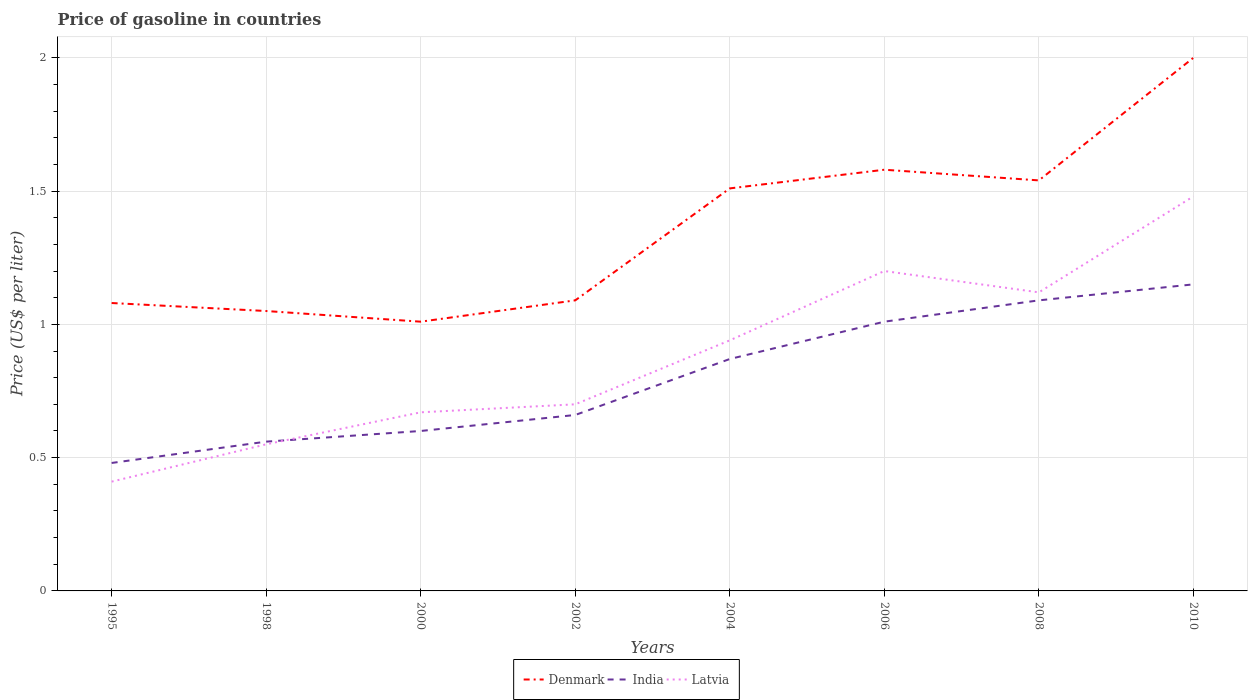How many different coloured lines are there?
Your answer should be compact. 3. Does the line corresponding to Latvia intersect with the line corresponding to India?
Provide a short and direct response. Yes. Across all years, what is the maximum price of gasoline in Latvia?
Give a very brief answer. 0.41. What is the total price of gasoline in Denmark in the graph?
Ensure brevity in your answer.  -0.08. What is the difference between the highest and the second highest price of gasoline in India?
Give a very brief answer. 0.67. What is the difference between the highest and the lowest price of gasoline in Latvia?
Your answer should be compact. 4. Is the price of gasoline in India strictly greater than the price of gasoline in Denmark over the years?
Make the answer very short. Yes. How many lines are there?
Give a very brief answer. 3. Are the values on the major ticks of Y-axis written in scientific E-notation?
Provide a short and direct response. No. Where does the legend appear in the graph?
Your answer should be very brief. Bottom center. How many legend labels are there?
Offer a very short reply. 3. What is the title of the graph?
Your answer should be very brief. Price of gasoline in countries. Does "Bosnia and Herzegovina" appear as one of the legend labels in the graph?
Keep it short and to the point. No. What is the label or title of the Y-axis?
Make the answer very short. Price (US$ per liter). What is the Price (US$ per liter) in India in 1995?
Your answer should be very brief. 0.48. What is the Price (US$ per liter) in Latvia in 1995?
Provide a succinct answer. 0.41. What is the Price (US$ per liter) in Denmark in 1998?
Offer a very short reply. 1.05. What is the Price (US$ per liter) in India in 1998?
Give a very brief answer. 0.56. What is the Price (US$ per liter) in Latvia in 1998?
Provide a short and direct response. 0.55. What is the Price (US$ per liter) of Denmark in 2000?
Your response must be concise. 1.01. What is the Price (US$ per liter) in Latvia in 2000?
Ensure brevity in your answer.  0.67. What is the Price (US$ per liter) in Denmark in 2002?
Offer a terse response. 1.09. What is the Price (US$ per liter) in India in 2002?
Your response must be concise. 0.66. What is the Price (US$ per liter) in Denmark in 2004?
Give a very brief answer. 1.51. What is the Price (US$ per liter) of India in 2004?
Make the answer very short. 0.87. What is the Price (US$ per liter) in Latvia in 2004?
Your answer should be very brief. 0.94. What is the Price (US$ per liter) in Denmark in 2006?
Provide a succinct answer. 1.58. What is the Price (US$ per liter) in India in 2006?
Your answer should be compact. 1.01. What is the Price (US$ per liter) in Latvia in 2006?
Your response must be concise. 1.2. What is the Price (US$ per liter) in Denmark in 2008?
Your answer should be very brief. 1.54. What is the Price (US$ per liter) of India in 2008?
Give a very brief answer. 1.09. What is the Price (US$ per liter) of Latvia in 2008?
Ensure brevity in your answer.  1.12. What is the Price (US$ per liter) of India in 2010?
Ensure brevity in your answer.  1.15. What is the Price (US$ per liter) of Latvia in 2010?
Offer a very short reply. 1.48. Across all years, what is the maximum Price (US$ per liter) of Denmark?
Offer a very short reply. 2. Across all years, what is the maximum Price (US$ per liter) of India?
Provide a short and direct response. 1.15. Across all years, what is the maximum Price (US$ per liter) in Latvia?
Make the answer very short. 1.48. Across all years, what is the minimum Price (US$ per liter) of Denmark?
Your response must be concise. 1.01. Across all years, what is the minimum Price (US$ per liter) in India?
Make the answer very short. 0.48. Across all years, what is the minimum Price (US$ per liter) in Latvia?
Make the answer very short. 0.41. What is the total Price (US$ per liter) of Denmark in the graph?
Make the answer very short. 10.86. What is the total Price (US$ per liter) in India in the graph?
Your answer should be very brief. 6.42. What is the total Price (US$ per liter) of Latvia in the graph?
Provide a short and direct response. 7.07. What is the difference between the Price (US$ per liter) in Denmark in 1995 and that in 1998?
Your response must be concise. 0.03. What is the difference between the Price (US$ per liter) in India in 1995 and that in 1998?
Your response must be concise. -0.08. What is the difference between the Price (US$ per liter) of Latvia in 1995 and that in 1998?
Your answer should be very brief. -0.14. What is the difference between the Price (US$ per liter) of Denmark in 1995 and that in 2000?
Provide a short and direct response. 0.07. What is the difference between the Price (US$ per liter) in India in 1995 and that in 2000?
Keep it short and to the point. -0.12. What is the difference between the Price (US$ per liter) in Latvia in 1995 and that in 2000?
Your response must be concise. -0.26. What is the difference between the Price (US$ per liter) in Denmark in 1995 and that in 2002?
Your answer should be compact. -0.01. What is the difference between the Price (US$ per liter) of India in 1995 and that in 2002?
Your answer should be compact. -0.18. What is the difference between the Price (US$ per liter) of Latvia in 1995 and that in 2002?
Your answer should be compact. -0.29. What is the difference between the Price (US$ per liter) of Denmark in 1995 and that in 2004?
Provide a short and direct response. -0.43. What is the difference between the Price (US$ per liter) in India in 1995 and that in 2004?
Make the answer very short. -0.39. What is the difference between the Price (US$ per liter) in Latvia in 1995 and that in 2004?
Make the answer very short. -0.53. What is the difference between the Price (US$ per liter) in Denmark in 1995 and that in 2006?
Offer a very short reply. -0.5. What is the difference between the Price (US$ per liter) of India in 1995 and that in 2006?
Make the answer very short. -0.53. What is the difference between the Price (US$ per liter) of Latvia in 1995 and that in 2006?
Offer a very short reply. -0.79. What is the difference between the Price (US$ per liter) in Denmark in 1995 and that in 2008?
Offer a very short reply. -0.46. What is the difference between the Price (US$ per liter) in India in 1995 and that in 2008?
Offer a very short reply. -0.61. What is the difference between the Price (US$ per liter) of Latvia in 1995 and that in 2008?
Provide a succinct answer. -0.71. What is the difference between the Price (US$ per liter) of Denmark in 1995 and that in 2010?
Your answer should be very brief. -0.92. What is the difference between the Price (US$ per liter) in India in 1995 and that in 2010?
Ensure brevity in your answer.  -0.67. What is the difference between the Price (US$ per liter) of Latvia in 1995 and that in 2010?
Make the answer very short. -1.07. What is the difference between the Price (US$ per liter) of India in 1998 and that in 2000?
Give a very brief answer. -0.04. What is the difference between the Price (US$ per liter) in Latvia in 1998 and that in 2000?
Give a very brief answer. -0.12. What is the difference between the Price (US$ per liter) of Denmark in 1998 and that in 2002?
Offer a terse response. -0.04. What is the difference between the Price (US$ per liter) of India in 1998 and that in 2002?
Offer a very short reply. -0.1. What is the difference between the Price (US$ per liter) of Denmark in 1998 and that in 2004?
Keep it short and to the point. -0.46. What is the difference between the Price (US$ per liter) of India in 1998 and that in 2004?
Make the answer very short. -0.31. What is the difference between the Price (US$ per liter) in Latvia in 1998 and that in 2004?
Offer a very short reply. -0.39. What is the difference between the Price (US$ per liter) of Denmark in 1998 and that in 2006?
Provide a succinct answer. -0.53. What is the difference between the Price (US$ per liter) in India in 1998 and that in 2006?
Give a very brief answer. -0.45. What is the difference between the Price (US$ per liter) in Latvia in 1998 and that in 2006?
Your answer should be very brief. -0.65. What is the difference between the Price (US$ per liter) of Denmark in 1998 and that in 2008?
Offer a very short reply. -0.49. What is the difference between the Price (US$ per liter) in India in 1998 and that in 2008?
Give a very brief answer. -0.53. What is the difference between the Price (US$ per liter) in Latvia in 1998 and that in 2008?
Your response must be concise. -0.57. What is the difference between the Price (US$ per liter) of Denmark in 1998 and that in 2010?
Give a very brief answer. -0.95. What is the difference between the Price (US$ per liter) of India in 1998 and that in 2010?
Offer a terse response. -0.59. What is the difference between the Price (US$ per liter) in Latvia in 1998 and that in 2010?
Your answer should be compact. -0.93. What is the difference between the Price (US$ per liter) of Denmark in 2000 and that in 2002?
Make the answer very short. -0.08. What is the difference between the Price (US$ per liter) of India in 2000 and that in 2002?
Keep it short and to the point. -0.06. What is the difference between the Price (US$ per liter) in Latvia in 2000 and that in 2002?
Make the answer very short. -0.03. What is the difference between the Price (US$ per liter) of India in 2000 and that in 2004?
Your answer should be very brief. -0.27. What is the difference between the Price (US$ per liter) of Latvia in 2000 and that in 2004?
Ensure brevity in your answer.  -0.27. What is the difference between the Price (US$ per liter) of Denmark in 2000 and that in 2006?
Give a very brief answer. -0.57. What is the difference between the Price (US$ per liter) in India in 2000 and that in 2006?
Your response must be concise. -0.41. What is the difference between the Price (US$ per liter) of Latvia in 2000 and that in 2006?
Keep it short and to the point. -0.53. What is the difference between the Price (US$ per liter) in Denmark in 2000 and that in 2008?
Ensure brevity in your answer.  -0.53. What is the difference between the Price (US$ per liter) in India in 2000 and that in 2008?
Keep it short and to the point. -0.49. What is the difference between the Price (US$ per liter) in Latvia in 2000 and that in 2008?
Keep it short and to the point. -0.45. What is the difference between the Price (US$ per liter) of Denmark in 2000 and that in 2010?
Give a very brief answer. -0.99. What is the difference between the Price (US$ per liter) of India in 2000 and that in 2010?
Your response must be concise. -0.55. What is the difference between the Price (US$ per liter) in Latvia in 2000 and that in 2010?
Provide a short and direct response. -0.81. What is the difference between the Price (US$ per liter) in Denmark in 2002 and that in 2004?
Your response must be concise. -0.42. What is the difference between the Price (US$ per liter) of India in 2002 and that in 2004?
Make the answer very short. -0.21. What is the difference between the Price (US$ per liter) in Latvia in 2002 and that in 2004?
Give a very brief answer. -0.24. What is the difference between the Price (US$ per liter) in Denmark in 2002 and that in 2006?
Keep it short and to the point. -0.49. What is the difference between the Price (US$ per liter) in India in 2002 and that in 2006?
Keep it short and to the point. -0.35. What is the difference between the Price (US$ per liter) in Latvia in 2002 and that in 2006?
Your response must be concise. -0.5. What is the difference between the Price (US$ per liter) of Denmark in 2002 and that in 2008?
Offer a very short reply. -0.45. What is the difference between the Price (US$ per liter) in India in 2002 and that in 2008?
Your answer should be compact. -0.43. What is the difference between the Price (US$ per liter) in Latvia in 2002 and that in 2008?
Your answer should be compact. -0.42. What is the difference between the Price (US$ per liter) of Denmark in 2002 and that in 2010?
Ensure brevity in your answer.  -0.91. What is the difference between the Price (US$ per liter) of India in 2002 and that in 2010?
Make the answer very short. -0.49. What is the difference between the Price (US$ per liter) of Latvia in 2002 and that in 2010?
Your response must be concise. -0.78. What is the difference between the Price (US$ per liter) of Denmark in 2004 and that in 2006?
Give a very brief answer. -0.07. What is the difference between the Price (US$ per liter) of India in 2004 and that in 2006?
Provide a short and direct response. -0.14. What is the difference between the Price (US$ per liter) of Latvia in 2004 and that in 2006?
Provide a succinct answer. -0.26. What is the difference between the Price (US$ per liter) of Denmark in 2004 and that in 2008?
Provide a short and direct response. -0.03. What is the difference between the Price (US$ per liter) in India in 2004 and that in 2008?
Keep it short and to the point. -0.22. What is the difference between the Price (US$ per liter) in Latvia in 2004 and that in 2008?
Provide a short and direct response. -0.18. What is the difference between the Price (US$ per liter) of Denmark in 2004 and that in 2010?
Offer a terse response. -0.49. What is the difference between the Price (US$ per liter) of India in 2004 and that in 2010?
Offer a very short reply. -0.28. What is the difference between the Price (US$ per liter) in Latvia in 2004 and that in 2010?
Your answer should be very brief. -0.54. What is the difference between the Price (US$ per liter) of Denmark in 2006 and that in 2008?
Make the answer very short. 0.04. What is the difference between the Price (US$ per liter) of India in 2006 and that in 2008?
Provide a short and direct response. -0.08. What is the difference between the Price (US$ per liter) of Latvia in 2006 and that in 2008?
Provide a succinct answer. 0.08. What is the difference between the Price (US$ per liter) of Denmark in 2006 and that in 2010?
Offer a terse response. -0.42. What is the difference between the Price (US$ per liter) in India in 2006 and that in 2010?
Keep it short and to the point. -0.14. What is the difference between the Price (US$ per liter) of Latvia in 2006 and that in 2010?
Offer a very short reply. -0.28. What is the difference between the Price (US$ per liter) in Denmark in 2008 and that in 2010?
Offer a very short reply. -0.46. What is the difference between the Price (US$ per liter) in India in 2008 and that in 2010?
Offer a very short reply. -0.06. What is the difference between the Price (US$ per liter) in Latvia in 2008 and that in 2010?
Your response must be concise. -0.36. What is the difference between the Price (US$ per liter) of Denmark in 1995 and the Price (US$ per liter) of India in 1998?
Offer a very short reply. 0.52. What is the difference between the Price (US$ per liter) of Denmark in 1995 and the Price (US$ per liter) of Latvia in 1998?
Give a very brief answer. 0.53. What is the difference between the Price (US$ per liter) of India in 1995 and the Price (US$ per liter) of Latvia in 1998?
Give a very brief answer. -0.07. What is the difference between the Price (US$ per liter) in Denmark in 1995 and the Price (US$ per liter) in India in 2000?
Your response must be concise. 0.48. What is the difference between the Price (US$ per liter) in Denmark in 1995 and the Price (US$ per liter) in Latvia in 2000?
Provide a succinct answer. 0.41. What is the difference between the Price (US$ per liter) of India in 1995 and the Price (US$ per liter) of Latvia in 2000?
Your answer should be very brief. -0.19. What is the difference between the Price (US$ per liter) of Denmark in 1995 and the Price (US$ per liter) of India in 2002?
Give a very brief answer. 0.42. What is the difference between the Price (US$ per liter) in Denmark in 1995 and the Price (US$ per liter) in Latvia in 2002?
Your answer should be very brief. 0.38. What is the difference between the Price (US$ per liter) of India in 1995 and the Price (US$ per liter) of Latvia in 2002?
Make the answer very short. -0.22. What is the difference between the Price (US$ per liter) in Denmark in 1995 and the Price (US$ per liter) in India in 2004?
Make the answer very short. 0.21. What is the difference between the Price (US$ per liter) of Denmark in 1995 and the Price (US$ per liter) of Latvia in 2004?
Offer a very short reply. 0.14. What is the difference between the Price (US$ per liter) of India in 1995 and the Price (US$ per liter) of Latvia in 2004?
Your answer should be very brief. -0.46. What is the difference between the Price (US$ per liter) of Denmark in 1995 and the Price (US$ per liter) of India in 2006?
Keep it short and to the point. 0.07. What is the difference between the Price (US$ per liter) of Denmark in 1995 and the Price (US$ per liter) of Latvia in 2006?
Keep it short and to the point. -0.12. What is the difference between the Price (US$ per liter) of India in 1995 and the Price (US$ per liter) of Latvia in 2006?
Your response must be concise. -0.72. What is the difference between the Price (US$ per liter) in Denmark in 1995 and the Price (US$ per liter) in India in 2008?
Your answer should be very brief. -0.01. What is the difference between the Price (US$ per liter) of Denmark in 1995 and the Price (US$ per liter) of Latvia in 2008?
Offer a very short reply. -0.04. What is the difference between the Price (US$ per liter) of India in 1995 and the Price (US$ per liter) of Latvia in 2008?
Keep it short and to the point. -0.64. What is the difference between the Price (US$ per liter) in Denmark in 1995 and the Price (US$ per liter) in India in 2010?
Your answer should be compact. -0.07. What is the difference between the Price (US$ per liter) of Denmark in 1995 and the Price (US$ per liter) of Latvia in 2010?
Offer a terse response. -0.4. What is the difference between the Price (US$ per liter) of India in 1995 and the Price (US$ per liter) of Latvia in 2010?
Offer a terse response. -1. What is the difference between the Price (US$ per liter) in Denmark in 1998 and the Price (US$ per liter) in India in 2000?
Keep it short and to the point. 0.45. What is the difference between the Price (US$ per liter) of Denmark in 1998 and the Price (US$ per liter) of Latvia in 2000?
Provide a succinct answer. 0.38. What is the difference between the Price (US$ per liter) in India in 1998 and the Price (US$ per liter) in Latvia in 2000?
Ensure brevity in your answer.  -0.11. What is the difference between the Price (US$ per liter) in Denmark in 1998 and the Price (US$ per liter) in India in 2002?
Keep it short and to the point. 0.39. What is the difference between the Price (US$ per liter) of India in 1998 and the Price (US$ per liter) of Latvia in 2002?
Your answer should be compact. -0.14. What is the difference between the Price (US$ per liter) in Denmark in 1998 and the Price (US$ per liter) in India in 2004?
Your answer should be compact. 0.18. What is the difference between the Price (US$ per liter) in Denmark in 1998 and the Price (US$ per liter) in Latvia in 2004?
Provide a succinct answer. 0.11. What is the difference between the Price (US$ per liter) of India in 1998 and the Price (US$ per liter) of Latvia in 2004?
Ensure brevity in your answer.  -0.38. What is the difference between the Price (US$ per liter) in Denmark in 1998 and the Price (US$ per liter) in Latvia in 2006?
Offer a very short reply. -0.15. What is the difference between the Price (US$ per liter) in India in 1998 and the Price (US$ per liter) in Latvia in 2006?
Make the answer very short. -0.64. What is the difference between the Price (US$ per liter) of Denmark in 1998 and the Price (US$ per liter) of India in 2008?
Offer a terse response. -0.04. What is the difference between the Price (US$ per liter) of Denmark in 1998 and the Price (US$ per liter) of Latvia in 2008?
Offer a terse response. -0.07. What is the difference between the Price (US$ per liter) of India in 1998 and the Price (US$ per liter) of Latvia in 2008?
Your response must be concise. -0.56. What is the difference between the Price (US$ per liter) in Denmark in 1998 and the Price (US$ per liter) in India in 2010?
Make the answer very short. -0.1. What is the difference between the Price (US$ per liter) in Denmark in 1998 and the Price (US$ per liter) in Latvia in 2010?
Your answer should be very brief. -0.43. What is the difference between the Price (US$ per liter) in India in 1998 and the Price (US$ per liter) in Latvia in 2010?
Offer a very short reply. -0.92. What is the difference between the Price (US$ per liter) in Denmark in 2000 and the Price (US$ per liter) in Latvia in 2002?
Provide a short and direct response. 0.31. What is the difference between the Price (US$ per liter) in India in 2000 and the Price (US$ per liter) in Latvia in 2002?
Keep it short and to the point. -0.1. What is the difference between the Price (US$ per liter) in Denmark in 2000 and the Price (US$ per liter) in India in 2004?
Provide a succinct answer. 0.14. What is the difference between the Price (US$ per liter) of Denmark in 2000 and the Price (US$ per liter) of Latvia in 2004?
Offer a very short reply. 0.07. What is the difference between the Price (US$ per liter) of India in 2000 and the Price (US$ per liter) of Latvia in 2004?
Offer a very short reply. -0.34. What is the difference between the Price (US$ per liter) of Denmark in 2000 and the Price (US$ per liter) of India in 2006?
Make the answer very short. 0. What is the difference between the Price (US$ per liter) in Denmark in 2000 and the Price (US$ per liter) in Latvia in 2006?
Offer a very short reply. -0.19. What is the difference between the Price (US$ per liter) of India in 2000 and the Price (US$ per liter) of Latvia in 2006?
Offer a very short reply. -0.6. What is the difference between the Price (US$ per liter) of Denmark in 2000 and the Price (US$ per liter) of India in 2008?
Your answer should be compact. -0.08. What is the difference between the Price (US$ per liter) of Denmark in 2000 and the Price (US$ per liter) of Latvia in 2008?
Provide a short and direct response. -0.11. What is the difference between the Price (US$ per liter) in India in 2000 and the Price (US$ per liter) in Latvia in 2008?
Offer a very short reply. -0.52. What is the difference between the Price (US$ per liter) in Denmark in 2000 and the Price (US$ per liter) in India in 2010?
Your answer should be very brief. -0.14. What is the difference between the Price (US$ per liter) in Denmark in 2000 and the Price (US$ per liter) in Latvia in 2010?
Offer a very short reply. -0.47. What is the difference between the Price (US$ per liter) in India in 2000 and the Price (US$ per liter) in Latvia in 2010?
Make the answer very short. -0.88. What is the difference between the Price (US$ per liter) of Denmark in 2002 and the Price (US$ per liter) of India in 2004?
Provide a short and direct response. 0.22. What is the difference between the Price (US$ per liter) in India in 2002 and the Price (US$ per liter) in Latvia in 2004?
Ensure brevity in your answer.  -0.28. What is the difference between the Price (US$ per liter) of Denmark in 2002 and the Price (US$ per liter) of Latvia in 2006?
Provide a succinct answer. -0.11. What is the difference between the Price (US$ per liter) of India in 2002 and the Price (US$ per liter) of Latvia in 2006?
Keep it short and to the point. -0.54. What is the difference between the Price (US$ per liter) of Denmark in 2002 and the Price (US$ per liter) of India in 2008?
Offer a terse response. 0. What is the difference between the Price (US$ per liter) of Denmark in 2002 and the Price (US$ per liter) of Latvia in 2008?
Provide a succinct answer. -0.03. What is the difference between the Price (US$ per liter) of India in 2002 and the Price (US$ per liter) of Latvia in 2008?
Give a very brief answer. -0.46. What is the difference between the Price (US$ per liter) of Denmark in 2002 and the Price (US$ per liter) of India in 2010?
Provide a succinct answer. -0.06. What is the difference between the Price (US$ per liter) in Denmark in 2002 and the Price (US$ per liter) in Latvia in 2010?
Make the answer very short. -0.39. What is the difference between the Price (US$ per liter) of India in 2002 and the Price (US$ per liter) of Latvia in 2010?
Your answer should be compact. -0.82. What is the difference between the Price (US$ per liter) in Denmark in 2004 and the Price (US$ per liter) in Latvia in 2006?
Make the answer very short. 0.31. What is the difference between the Price (US$ per liter) of India in 2004 and the Price (US$ per liter) of Latvia in 2006?
Offer a terse response. -0.33. What is the difference between the Price (US$ per liter) in Denmark in 2004 and the Price (US$ per liter) in India in 2008?
Ensure brevity in your answer.  0.42. What is the difference between the Price (US$ per liter) in Denmark in 2004 and the Price (US$ per liter) in Latvia in 2008?
Your answer should be compact. 0.39. What is the difference between the Price (US$ per liter) of India in 2004 and the Price (US$ per liter) of Latvia in 2008?
Provide a succinct answer. -0.25. What is the difference between the Price (US$ per liter) of Denmark in 2004 and the Price (US$ per liter) of India in 2010?
Make the answer very short. 0.36. What is the difference between the Price (US$ per liter) of Denmark in 2004 and the Price (US$ per liter) of Latvia in 2010?
Your answer should be compact. 0.03. What is the difference between the Price (US$ per liter) in India in 2004 and the Price (US$ per liter) in Latvia in 2010?
Your answer should be compact. -0.61. What is the difference between the Price (US$ per liter) in Denmark in 2006 and the Price (US$ per liter) in India in 2008?
Give a very brief answer. 0.49. What is the difference between the Price (US$ per liter) of Denmark in 2006 and the Price (US$ per liter) of Latvia in 2008?
Give a very brief answer. 0.46. What is the difference between the Price (US$ per liter) of India in 2006 and the Price (US$ per liter) of Latvia in 2008?
Your answer should be very brief. -0.11. What is the difference between the Price (US$ per liter) of Denmark in 2006 and the Price (US$ per liter) of India in 2010?
Provide a short and direct response. 0.43. What is the difference between the Price (US$ per liter) in Denmark in 2006 and the Price (US$ per liter) in Latvia in 2010?
Offer a terse response. 0.1. What is the difference between the Price (US$ per liter) in India in 2006 and the Price (US$ per liter) in Latvia in 2010?
Give a very brief answer. -0.47. What is the difference between the Price (US$ per liter) in Denmark in 2008 and the Price (US$ per liter) in India in 2010?
Give a very brief answer. 0.39. What is the difference between the Price (US$ per liter) of Denmark in 2008 and the Price (US$ per liter) of Latvia in 2010?
Make the answer very short. 0.06. What is the difference between the Price (US$ per liter) in India in 2008 and the Price (US$ per liter) in Latvia in 2010?
Give a very brief answer. -0.39. What is the average Price (US$ per liter) of Denmark per year?
Keep it short and to the point. 1.36. What is the average Price (US$ per liter) of India per year?
Give a very brief answer. 0.8. What is the average Price (US$ per liter) of Latvia per year?
Offer a very short reply. 0.88. In the year 1995, what is the difference between the Price (US$ per liter) in Denmark and Price (US$ per liter) in Latvia?
Offer a terse response. 0.67. In the year 1995, what is the difference between the Price (US$ per liter) in India and Price (US$ per liter) in Latvia?
Provide a succinct answer. 0.07. In the year 1998, what is the difference between the Price (US$ per liter) of Denmark and Price (US$ per liter) of India?
Offer a very short reply. 0.49. In the year 2000, what is the difference between the Price (US$ per liter) of Denmark and Price (US$ per liter) of India?
Your answer should be compact. 0.41. In the year 2000, what is the difference between the Price (US$ per liter) of Denmark and Price (US$ per liter) of Latvia?
Your answer should be compact. 0.34. In the year 2000, what is the difference between the Price (US$ per liter) of India and Price (US$ per liter) of Latvia?
Keep it short and to the point. -0.07. In the year 2002, what is the difference between the Price (US$ per liter) in Denmark and Price (US$ per liter) in India?
Ensure brevity in your answer.  0.43. In the year 2002, what is the difference between the Price (US$ per liter) of Denmark and Price (US$ per liter) of Latvia?
Your response must be concise. 0.39. In the year 2002, what is the difference between the Price (US$ per liter) in India and Price (US$ per liter) in Latvia?
Provide a succinct answer. -0.04. In the year 2004, what is the difference between the Price (US$ per liter) in Denmark and Price (US$ per liter) in India?
Provide a succinct answer. 0.64. In the year 2004, what is the difference between the Price (US$ per liter) of Denmark and Price (US$ per liter) of Latvia?
Make the answer very short. 0.57. In the year 2004, what is the difference between the Price (US$ per liter) of India and Price (US$ per liter) of Latvia?
Make the answer very short. -0.07. In the year 2006, what is the difference between the Price (US$ per liter) of Denmark and Price (US$ per liter) of India?
Offer a very short reply. 0.57. In the year 2006, what is the difference between the Price (US$ per liter) in Denmark and Price (US$ per liter) in Latvia?
Your answer should be compact. 0.38. In the year 2006, what is the difference between the Price (US$ per liter) in India and Price (US$ per liter) in Latvia?
Ensure brevity in your answer.  -0.19. In the year 2008, what is the difference between the Price (US$ per liter) in Denmark and Price (US$ per liter) in India?
Give a very brief answer. 0.45. In the year 2008, what is the difference between the Price (US$ per liter) in Denmark and Price (US$ per liter) in Latvia?
Provide a succinct answer. 0.42. In the year 2008, what is the difference between the Price (US$ per liter) in India and Price (US$ per liter) in Latvia?
Provide a succinct answer. -0.03. In the year 2010, what is the difference between the Price (US$ per liter) of Denmark and Price (US$ per liter) of Latvia?
Offer a very short reply. 0.52. In the year 2010, what is the difference between the Price (US$ per liter) of India and Price (US$ per liter) of Latvia?
Your response must be concise. -0.33. What is the ratio of the Price (US$ per liter) of Denmark in 1995 to that in 1998?
Your answer should be compact. 1.03. What is the ratio of the Price (US$ per liter) in India in 1995 to that in 1998?
Provide a short and direct response. 0.86. What is the ratio of the Price (US$ per liter) in Latvia in 1995 to that in 1998?
Your response must be concise. 0.75. What is the ratio of the Price (US$ per liter) of Denmark in 1995 to that in 2000?
Make the answer very short. 1.07. What is the ratio of the Price (US$ per liter) in India in 1995 to that in 2000?
Offer a very short reply. 0.8. What is the ratio of the Price (US$ per liter) of Latvia in 1995 to that in 2000?
Make the answer very short. 0.61. What is the ratio of the Price (US$ per liter) of Denmark in 1995 to that in 2002?
Ensure brevity in your answer.  0.99. What is the ratio of the Price (US$ per liter) of India in 1995 to that in 2002?
Provide a succinct answer. 0.73. What is the ratio of the Price (US$ per liter) in Latvia in 1995 to that in 2002?
Your answer should be very brief. 0.59. What is the ratio of the Price (US$ per liter) in Denmark in 1995 to that in 2004?
Offer a very short reply. 0.72. What is the ratio of the Price (US$ per liter) of India in 1995 to that in 2004?
Provide a short and direct response. 0.55. What is the ratio of the Price (US$ per liter) of Latvia in 1995 to that in 2004?
Offer a very short reply. 0.44. What is the ratio of the Price (US$ per liter) of Denmark in 1995 to that in 2006?
Your answer should be very brief. 0.68. What is the ratio of the Price (US$ per liter) in India in 1995 to that in 2006?
Make the answer very short. 0.48. What is the ratio of the Price (US$ per liter) in Latvia in 1995 to that in 2006?
Make the answer very short. 0.34. What is the ratio of the Price (US$ per liter) in Denmark in 1995 to that in 2008?
Your answer should be compact. 0.7. What is the ratio of the Price (US$ per liter) in India in 1995 to that in 2008?
Provide a short and direct response. 0.44. What is the ratio of the Price (US$ per liter) in Latvia in 1995 to that in 2008?
Your answer should be compact. 0.37. What is the ratio of the Price (US$ per liter) in Denmark in 1995 to that in 2010?
Keep it short and to the point. 0.54. What is the ratio of the Price (US$ per liter) in India in 1995 to that in 2010?
Your answer should be compact. 0.42. What is the ratio of the Price (US$ per liter) of Latvia in 1995 to that in 2010?
Keep it short and to the point. 0.28. What is the ratio of the Price (US$ per liter) of Denmark in 1998 to that in 2000?
Your answer should be very brief. 1.04. What is the ratio of the Price (US$ per liter) of Latvia in 1998 to that in 2000?
Offer a very short reply. 0.82. What is the ratio of the Price (US$ per liter) in Denmark in 1998 to that in 2002?
Provide a short and direct response. 0.96. What is the ratio of the Price (US$ per liter) in India in 1998 to that in 2002?
Provide a short and direct response. 0.85. What is the ratio of the Price (US$ per liter) of Latvia in 1998 to that in 2002?
Give a very brief answer. 0.79. What is the ratio of the Price (US$ per liter) in Denmark in 1998 to that in 2004?
Give a very brief answer. 0.7. What is the ratio of the Price (US$ per liter) of India in 1998 to that in 2004?
Your answer should be compact. 0.64. What is the ratio of the Price (US$ per liter) of Latvia in 1998 to that in 2004?
Ensure brevity in your answer.  0.59. What is the ratio of the Price (US$ per liter) in Denmark in 1998 to that in 2006?
Offer a terse response. 0.66. What is the ratio of the Price (US$ per liter) of India in 1998 to that in 2006?
Ensure brevity in your answer.  0.55. What is the ratio of the Price (US$ per liter) in Latvia in 1998 to that in 2006?
Give a very brief answer. 0.46. What is the ratio of the Price (US$ per liter) in Denmark in 1998 to that in 2008?
Provide a short and direct response. 0.68. What is the ratio of the Price (US$ per liter) in India in 1998 to that in 2008?
Your answer should be very brief. 0.51. What is the ratio of the Price (US$ per liter) in Latvia in 1998 to that in 2008?
Keep it short and to the point. 0.49. What is the ratio of the Price (US$ per liter) of Denmark in 1998 to that in 2010?
Provide a succinct answer. 0.53. What is the ratio of the Price (US$ per liter) in India in 1998 to that in 2010?
Make the answer very short. 0.49. What is the ratio of the Price (US$ per liter) in Latvia in 1998 to that in 2010?
Your answer should be compact. 0.37. What is the ratio of the Price (US$ per liter) of Denmark in 2000 to that in 2002?
Provide a succinct answer. 0.93. What is the ratio of the Price (US$ per liter) of Latvia in 2000 to that in 2002?
Keep it short and to the point. 0.96. What is the ratio of the Price (US$ per liter) in Denmark in 2000 to that in 2004?
Give a very brief answer. 0.67. What is the ratio of the Price (US$ per liter) of India in 2000 to that in 2004?
Provide a short and direct response. 0.69. What is the ratio of the Price (US$ per liter) in Latvia in 2000 to that in 2004?
Your answer should be very brief. 0.71. What is the ratio of the Price (US$ per liter) in Denmark in 2000 to that in 2006?
Your response must be concise. 0.64. What is the ratio of the Price (US$ per liter) of India in 2000 to that in 2006?
Give a very brief answer. 0.59. What is the ratio of the Price (US$ per liter) of Latvia in 2000 to that in 2006?
Your answer should be compact. 0.56. What is the ratio of the Price (US$ per liter) in Denmark in 2000 to that in 2008?
Your answer should be very brief. 0.66. What is the ratio of the Price (US$ per liter) in India in 2000 to that in 2008?
Provide a succinct answer. 0.55. What is the ratio of the Price (US$ per liter) in Latvia in 2000 to that in 2008?
Your response must be concise. 0.6. What is the ratio of the Price (US$ per liter) of Denmark in 2000 to that in 2010?
Ensure brevity in your answer.  0.51. What is the ratio of the Price (US$ per liter) in India in 2000 to that in 2010?
Provide a succinct answer. 0.52. What is the ratio of the Price (US$ per liter) of Latvia in 2000 to that in 2010?
Give a very brief answer. 0.45. What is the ratio of the Price (US$ per liter) in Denmark in 2002 to that in 2004?
Your answer should be very brief. 0.72. What is the ratio of the Price (US$ per liter) of India in 2002 to that in 2004?
Offer a terse response. 0.76. What is the ratio of the Price (US$ per liter) in Latvia in 2002 to that in 2004?
Make the answer very short. 0.74. What is the ratio of the Price (US$ per liter) of Denmark in 2002 to that in 2006?
Provide a short and direct response. 0.69. What is the ratio of the Price (US$ per liter) of India in 2002 to that in 2006?
Ensure brevity in your answer.  0.65. What is the ratio of the Price (US$ per liter) in Latvia in 2002 to that in 2006?
Your answer should be very brief. 0.58. What is the ratio of the Price (US$ per liter) in Denmark in 2002 to that in 2008?
Your response must be concise. 0.71. What is the ratio of the Price (US$ per liter) in India in 2002 to that in 2008?
Provide a succinct answer. 0.61. What is the ratio of the Price (US$ per liter) in Denmark in 2002 to that in 2010?
Your answer should be compact. 0.55. What is the ratio of the Price (US$ per liter) in India in 2002 to that in 2010?
Your answer should be very brief. 0.57. What is the ratio of the Price (US$ per liter) of Latvia in 2002 to that in 2010?
Offer a very short reply. 0.47. What is the ratio of the Price (US$ per liter) in Denmark in 2004 to that in 2006?
Provide a short and direct response. 0.96. What is the ratio of the Price (US$ per liter) in India in 2004 to that in 2006?
Make the answer very short. 0.86. What is the ratio of the Price (US$ per liter) in Latvia in 2004 to that in 2006?
Offer a terse response. 0.78. What is the ratio of the Price (US$ per liter) of Denmark in 2004 to that in 2008?
Make the answer very short. 0.98. What is the ratio of the Price (US$ per liter) in India in 2004 to that in 2008?
Your answer should be very brief. 0.8. What is the ratio of the Price (US$ per liter) of Latvia in 2004 to that in 2008?
Keep it short and to the point. 0.84. What is the ratio of the Price (US$ per liter) of Denmark in 2004 to that in 2010?
Keep it short and to the point. 0.76. What is the ratio of the Price (US$ per liter) of India in 2004 to that in 2010?
Keep it short and to the point. 0.76. What is the ratio of the Price (US$ per liter) of Latvia in 2004 to that in 2010?
Your answer should be very brief. 0.64. What is the ratio of the Price (US$ per liter) of India in 2006 to that in 2008?
Your response must be concise. 0.93. What is the ratio of the Price (US$ per liter) of Latvia in 2006 to that in 2008?
Your response must be concise. 1.07. What is the ratio of the Price (US$ per liter) in Denmark in 2006 to that in 2010?
Provide a succinct answer. 0.79. What is the ratio of the Price (US$ per liter) of India in 2006 to that in 2010?
Offer a very short reply. 0.88. What is the ratio of the Price (US$ per liter) in Latvia in 2006 to that in 2010?
Provide a succinct answer. 0.81. What is the ratio of the Price (US$ per liter) of Denmark in 2008 to that in 2010?
Offer a very short reply. 0.77. What is the ratio of the Price (US$ per liter) of India in 2008 to that in 2010?
Provide a short and direct response. 0.95. What is the ratio of the Price (US$ per liter) in Latvia in 2008 to that in 2010?
Your answer should be compact. 0.76. What is the difference between the highest and the second highest Price (US$ per liter) of Denmark?
Provide a short and direct response. 0.42. What is the difference between the highest and the second highest Price (US$ per liter) in Latvia?
Give a very brief answer. 0.28. What is the difference between the highest and the lowest Price (US$ per liter) of India?
Give a very brief answer. 0.67. What is the difference between the highest and the lowest Price (US$ per liter) in Latvia?
Keep it short and to the point. 1.07. 